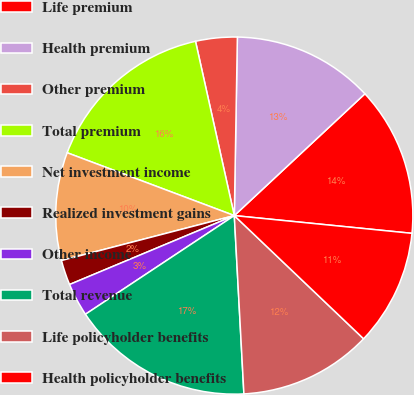Convert chart. <chart><loc_0><loc_0><loc_500><loc_500><pie_chart><fcel>Life premium<fcel>Health premium<fcel>Other premium<fcel>Total premium<fcel>Net investment income<fcel>Realized investment gains<fcel>Other income<fcel>Total revenue<fcel>Life policyholder benefits<fcel>Health policyholder benefits<nl><fcel>13.53%<fcel>12.78%<fcel>3.76%<fcel>15.79%<fcel>9.77%<fcel>2.26%<fcel>3.01%<fcel>16.54%<fcel>12.03%<fcel>10.53%<nl></chart> 